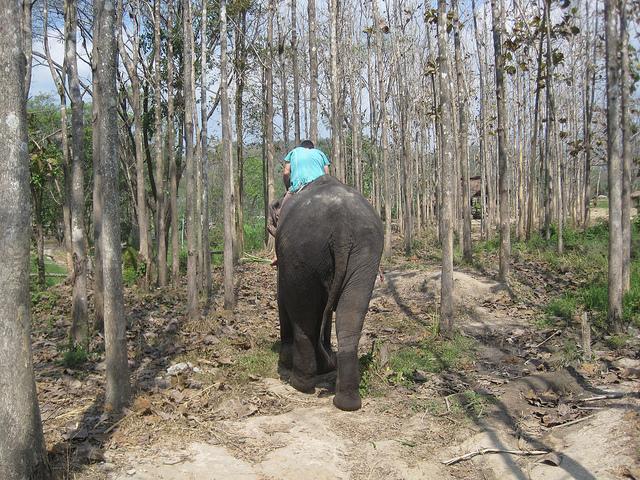How many zebras are shown?
Give a very brief answer. 0. 